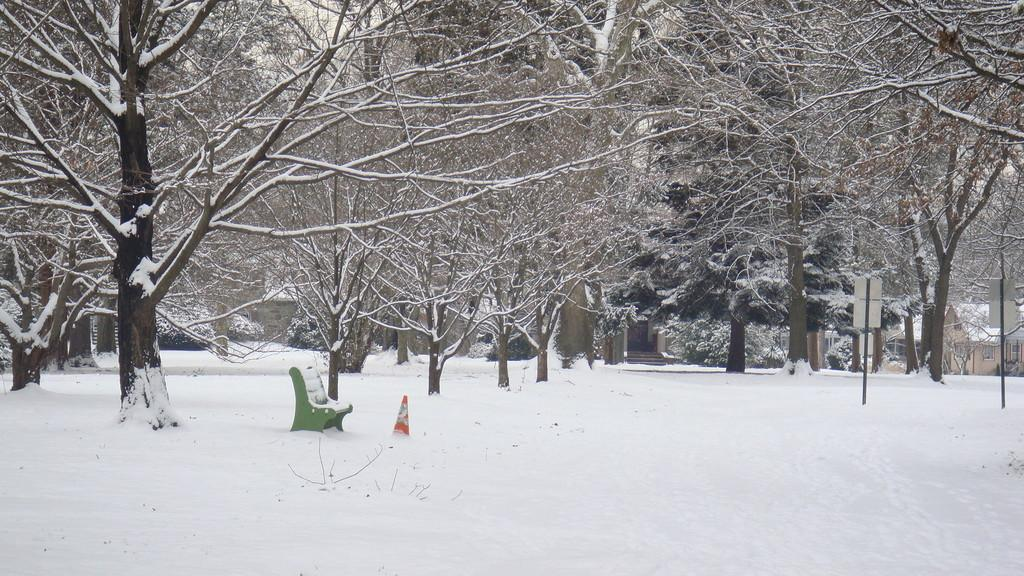What is the weather like in the image? There is snow in the image, indicating a cold and likely wintery weather. What type of outdoor furniture can be seen in the image? There is a bench in the image. What safety object is present in the image? A traffic cone is present in the image. What type of structures are in the image? There are poles and boards in the image. What can be seen in the background of the image? There are many trees in the background of the image. What type of shade is provided by the trees in the image? There is no mention of shade in the image, as the trees are likely covered in snow and not providing shade. What root system can be seen growing from the traffic cone in the image? There is no root system present in the image, as traffic cones are man-made objects and do not have roots. 